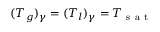Convert formula to latex. <formula><loc_0><loc_0><loc_500><loc_500>( T _ { g } ) _ { \gamma } = ( T _ { l } ) _ { \gamma } = T _ { s a t }</formula> 